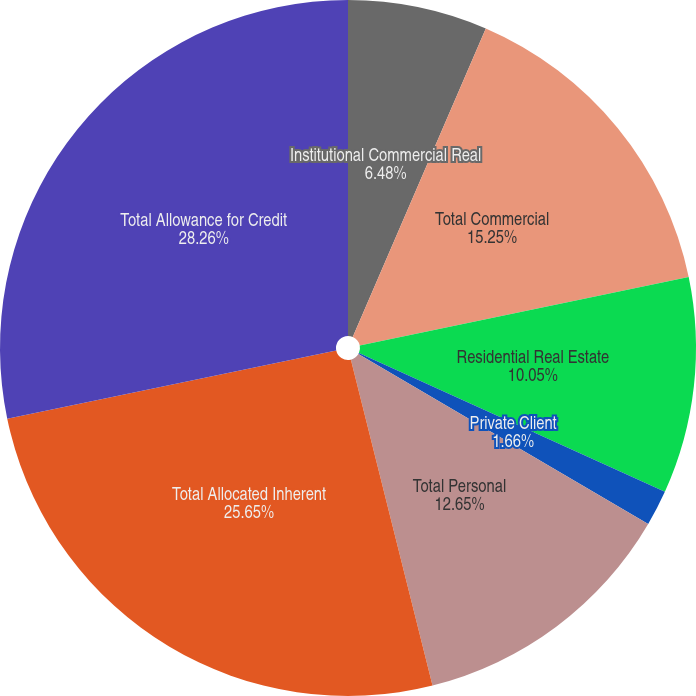Convert chart to OTSL. <chart><loc_0><loc_0><loc_500><loc_500><pie_chart><fcel>Institutional Commercial Real<fcel>Total Commercial<fcel>Residential Real Estate<fcel>Private Client<fcel>Total Personal<fcel>Total Allocated Inherent<fcel>Total Allowance for Credit<nl><fcel>6.48%<fcel>15.25%<fcel>10.05%<fcel>1.66%<fcel>12.65%<fcel>25.65%<fcel>28.25%<nl></chart> 